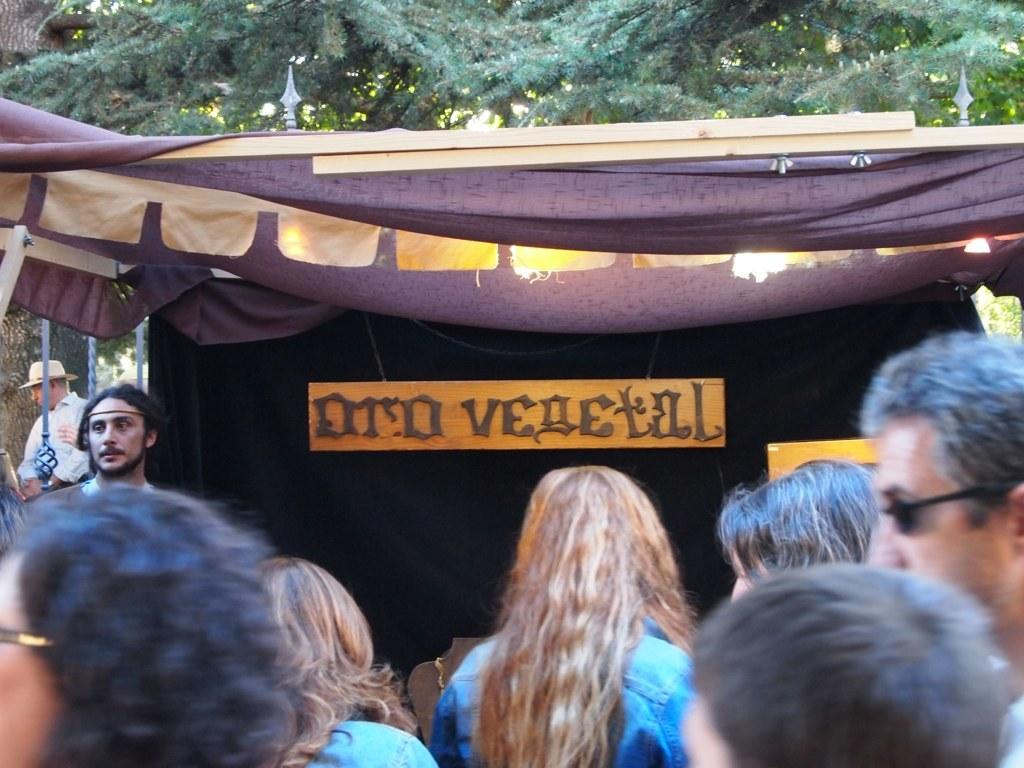How many people are in the image? There is a group of people in the image, but the exact number cannot be determined from the provided facts. What can be seen in the background of the image? There is a tree visible in the image. What type of shelter is present in the image? There is a tent in the image. What is on the tent? There is a board on the tent. What type of birth can be seen taking place in the image? There is no birth taking place in the image; it features a group of people, a tree, a tent, and a board on the tent. What type of song is being sung by the people in the image? There is no indication in the image that the people are singing a song. 